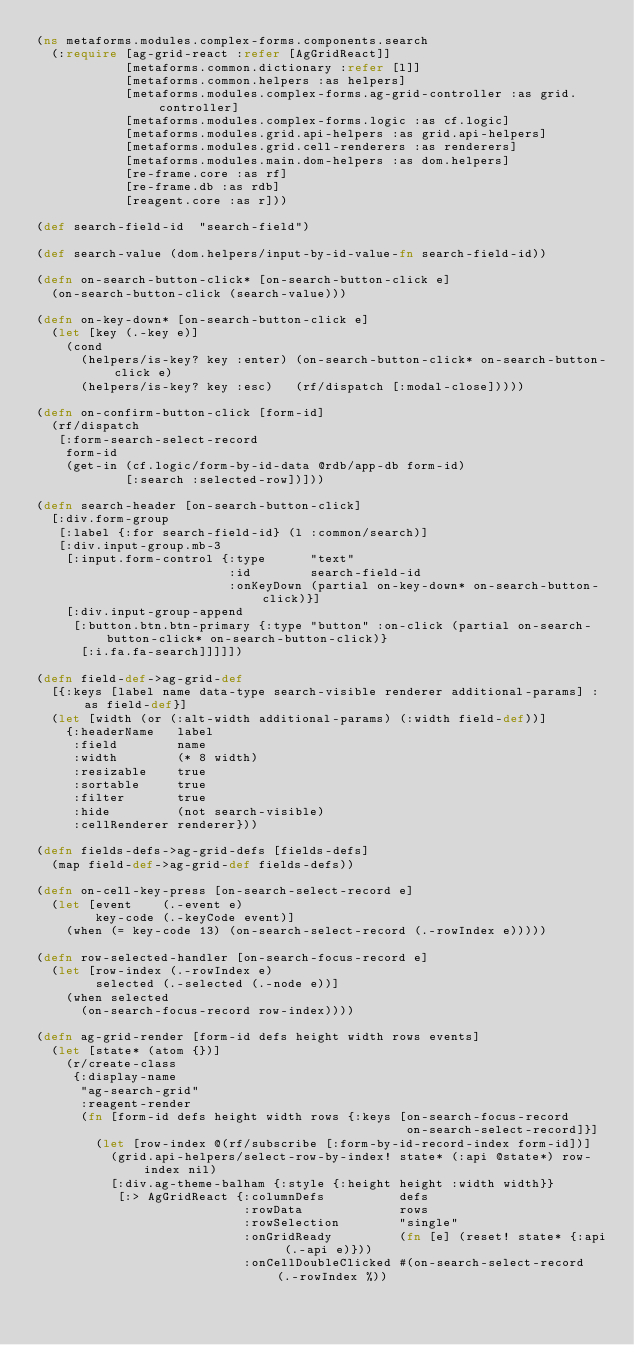Convert code to text. <code><loc_0><loc_0><loc_500><loc_500><_Clojure_>(ns metaforms.modules.complex-forms.components.search
  (:require [ag-grid-react :refer [AgGridReact]]
            [metaforms.common.dictionary :refer [l]]
            [metaforms.common.helpers :as helpers]
            [metaforms.modules.complex-forms.ag-grid-controller :as grid.controller]
            [metaforms.modules.complex-forms.logic :as cf.logic]
            [metaforms.modules.grid.api-helpers :as grid.api-helpers]
            [metaforms.modules.grid.cell-renderers :as renderers]
            [metaforms.modules.main.dom-helpers :as dom.helpers]
            [re-frame.core :as rf]
            [re-frame.db :as rdb]
            [reagent.core :as r]))

(def search-field-id  "search-field")

(def search-value (dom.helpers/input-by-id-value-fn search-field-id))

(defn on-search-button-click* [on-search-button-click e]
  (on-search-button-click (search-value)))

(defn on-key-down* [on-search-button-click e]
  (let [key (.-key e)]
    (cond
      (helpers/is-key? key :enter) (on-search-button-click* on-search-button-click e)
      (helpers/is-key? key :esc)   (rf/dispatch [:modal-close]))))

(defn on-confirm-button-click [form-id]
  (rf/dispatch
   [:form-search-select-record
    form-id
    (get-in (cf.logic/form-by-id-data @rdb/app-db form-id)
            [:search :selected-row])]))

(defn search-header [on-search-button-click]
  [:div.form-group
   [:label {:for search-field-id} (l :common/search)]
   [:div.input-group.mb-3
    [:input.form-control {:type      "text"
                          :id        search-field-id
                          :onKeyDown (partial on-key-down* on-search-button-click)}]
    [:div.input-group-append
     [:button.btn.btn-primary {:type "button" :on-click (partial on-search-button-click* on-search-button-click)}
      [:i.fa.fa-search]]]]])

(defn field-def->ag-grid-def
  [{:keys [label name data-type search-visible renderer additional-params] :as field-def}]
  (let [width (or (:alt-width additional-params) (:width field-def))]
    {:headerName   label
     :field        name
     :width        (* 8 width)
     :resizable    true
     :sortable     true
     :filter       true
     :hide         (not search-visible)
     :cellRenderer renderer}))

(defn fields-defs->ag-grid-defs [fields-defs]
  (map field-def->ag-grid-def fields-defs))

(defn on-cell-key-press [on-search-select-record e]
  (let [event    (.-event e)
        key-code (.-keyCode event)]
    (when (= key-code 13) (on-search-select-record (.-rowIndex e)))))

(defn row-selected-handler [on-search-focus-record e]
  (let [row-index (.-rowIndex e)
        selected (.-selected (.-node e))]
    (when selected
      (on-search-focus-record row-index))))

(defn ag-grid-render [form-id defs height width rows events]
  (let [state* (atom {})]
    (r/create-class
     {:display-name
      "ag-search-grid"
      :reagent-render
      (fn [form-id defs height width rows {:keys [on-search-focus-record
                                                  on-search-select-record]}]
        (let [row-index @(rf/subscribe [:form-by-id-record-index form-id])]
          (grid.api-helpers/select-row-by-index! state* (:api @state*) row-index nil)
          [:div.ag-theme-balham {:style {:height height :width width}}
           [:> AgGridReact {:columnDefs          defs
                            :rowData             rows
                            :rowSelection        "single"
                            :onGridReady         (fn [e] (reset! state* {:api (.-api e)}))
                            :onCellDoubleClicked #(on-search-select-record (.-rowIndex %))</code> 